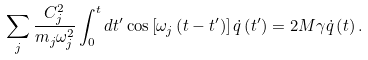<formula> <loc_0><loc_0><loc_500><loc_500>\sum _ { j } \frac { C _ { j } ^ { 2 } } { m _ { j } \omega _ { j } ^ { 2 } } \int _ { 0 } ^ { t } d t ^ { \prime } \cos \left [ \omega _ { j } \left ( t - t ^ { \prime } \right ) \right ] \dot { q } \left ( t ^ { \prime } \right ) = 2 M \gamma \dot { q } \left ( t \right ) .</formula> 